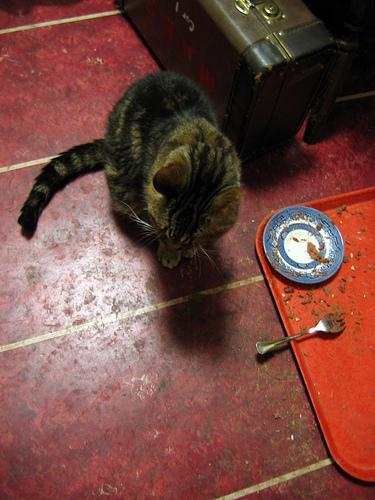Question: what type of animal is in this picture?
Choices:
A. Cat.
B. Cow.
C. Dog.
D. Pig.
Answer with the letter. Answer: A Question: what was the cat doing?
Choices:
A. Drinking.
B. Purring.
C. Playing.
D. Eating.
Answer with the letter. Answer: D Question: how many animals are in this picture?
Choices:
A. 2.
B. 3.
C. 1.
D. 4.
Answer with the letter. Answer: C Question: what color is the tray?
Choices:
A. Red.
B. Yellow.
C. Green.
D. Orange.
Answer with the letter. Answer: D Question: what utensil is in this picture?
Choices:
A. Fork.
B. Knife.
C. Spoon.
D. Spatula.
Answer with the letter. Answer: A 